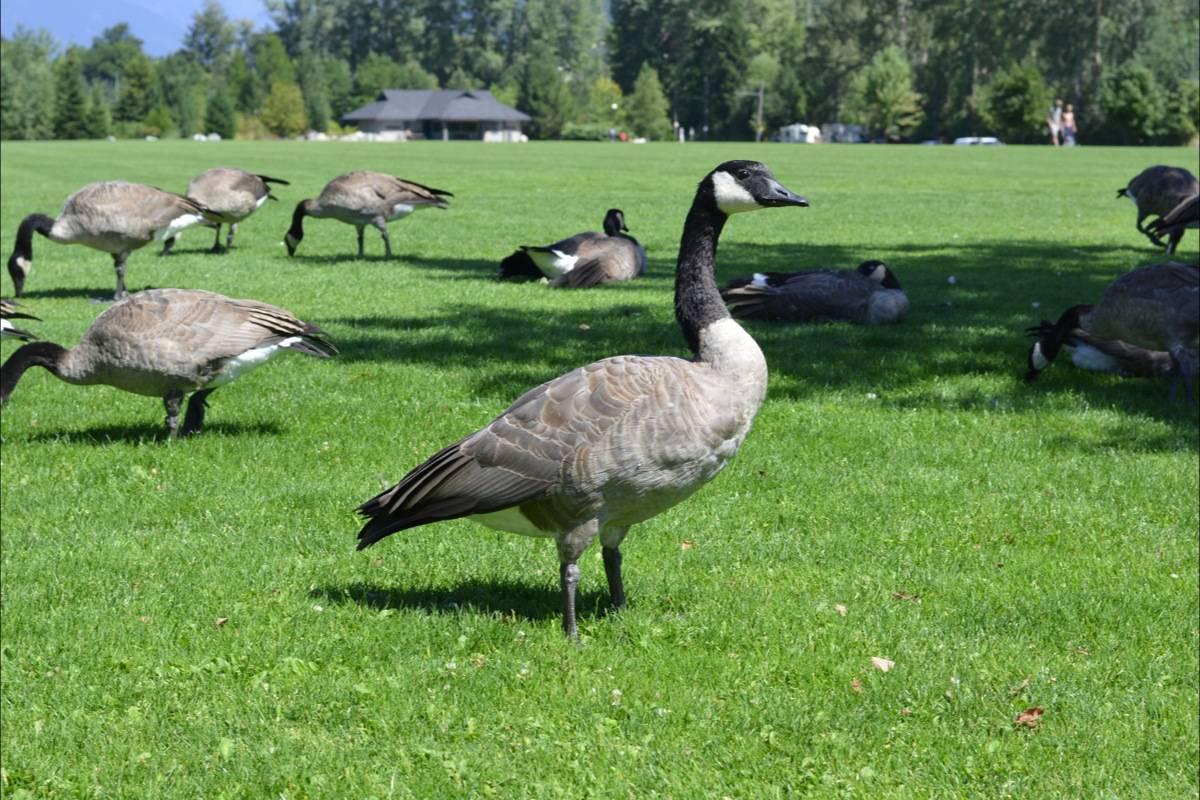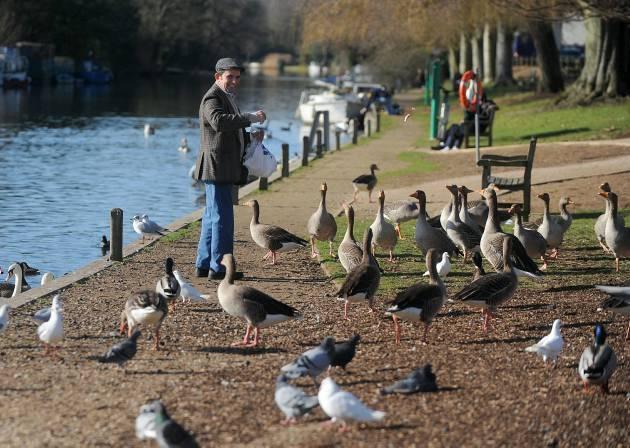The first image is the image on the left, the second image is the image on the right. Given the left and right images, does the statement "There is a man among a flock of geese in an outdoor setting" hold true? Answer yes or no. Yes. The first image is the image on the left, the second image is the image on the right. Analyze the images presented: Is the assertion "There is a person near the birds in one of the images." valid? Answer yes or no. Yes. 